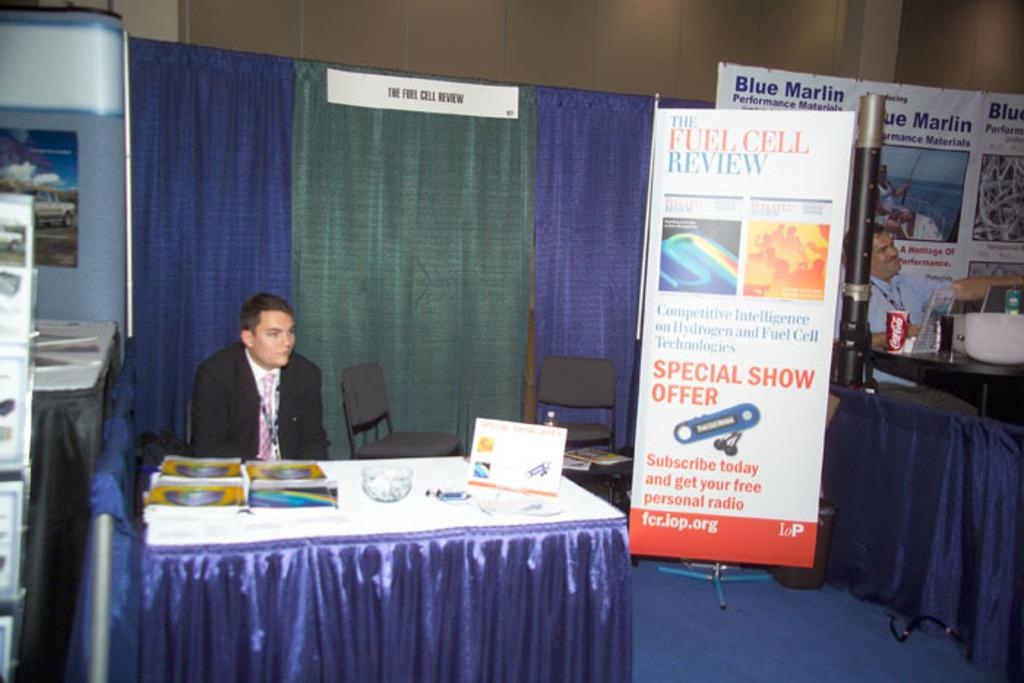Provide a one-sentence caption for the provided image. a man sitting next to a special show offer sign. 